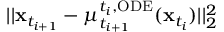<formula> <loc_0><loc_0><loc_500><loc_500>| | x _ { t _ { i + 1 } } - \mu _ { t _ { i + 1 } } ^ { t _ { i } , O D E } ( x _ { t _ { i } } ) | | _ { 2 } ^ { 2 }</formula> 